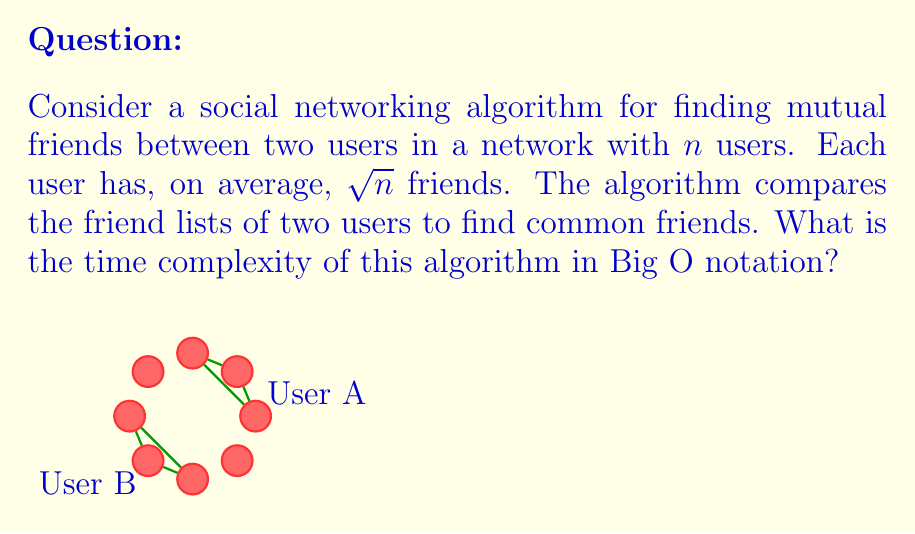Provide a solution to this math problem. Let's analyze this step-by-step:

1) First, we need to understand what the algorithm does:
   - It takes two users' friend lists
   - It compares these lists to find common friends

2) Now, let's consider the size of these friend lists:
   - There are $n$ users in total
   - Each user has, on average, $\sqrt{n}$ friends

3) To find mutual friends, the algorithm needs to compare each friend in one user's list with each friend in the other user's list:
   - User A has $\sqrt{n}$ friends
   - User B has $\sqrt{n}$ friends
   - We need to compare each of A's friends with each of B's friends

4) This comparison is essentially a nested loop:
   - The outer loop runs $\sqrt{n}$ times (for each of A's friends)
   - The inner loop runs $\sqrt{n}$ times (for each of B's friends)

5) The total number of comparisons is therefore:
   $$ \sqrt{n} * \sqrt{n} = n $$

6) Each comparison is assumed to take constant time $O(1)$

7) Therefore, the total time complexity is $O(n)$

This algorithm is efficient for a social networking context, as it scales linearly with the number of users, making it suitable for large networks where users typically have a number of friends proportional to the square root of the total user base.
Answer: $O(n)$ 